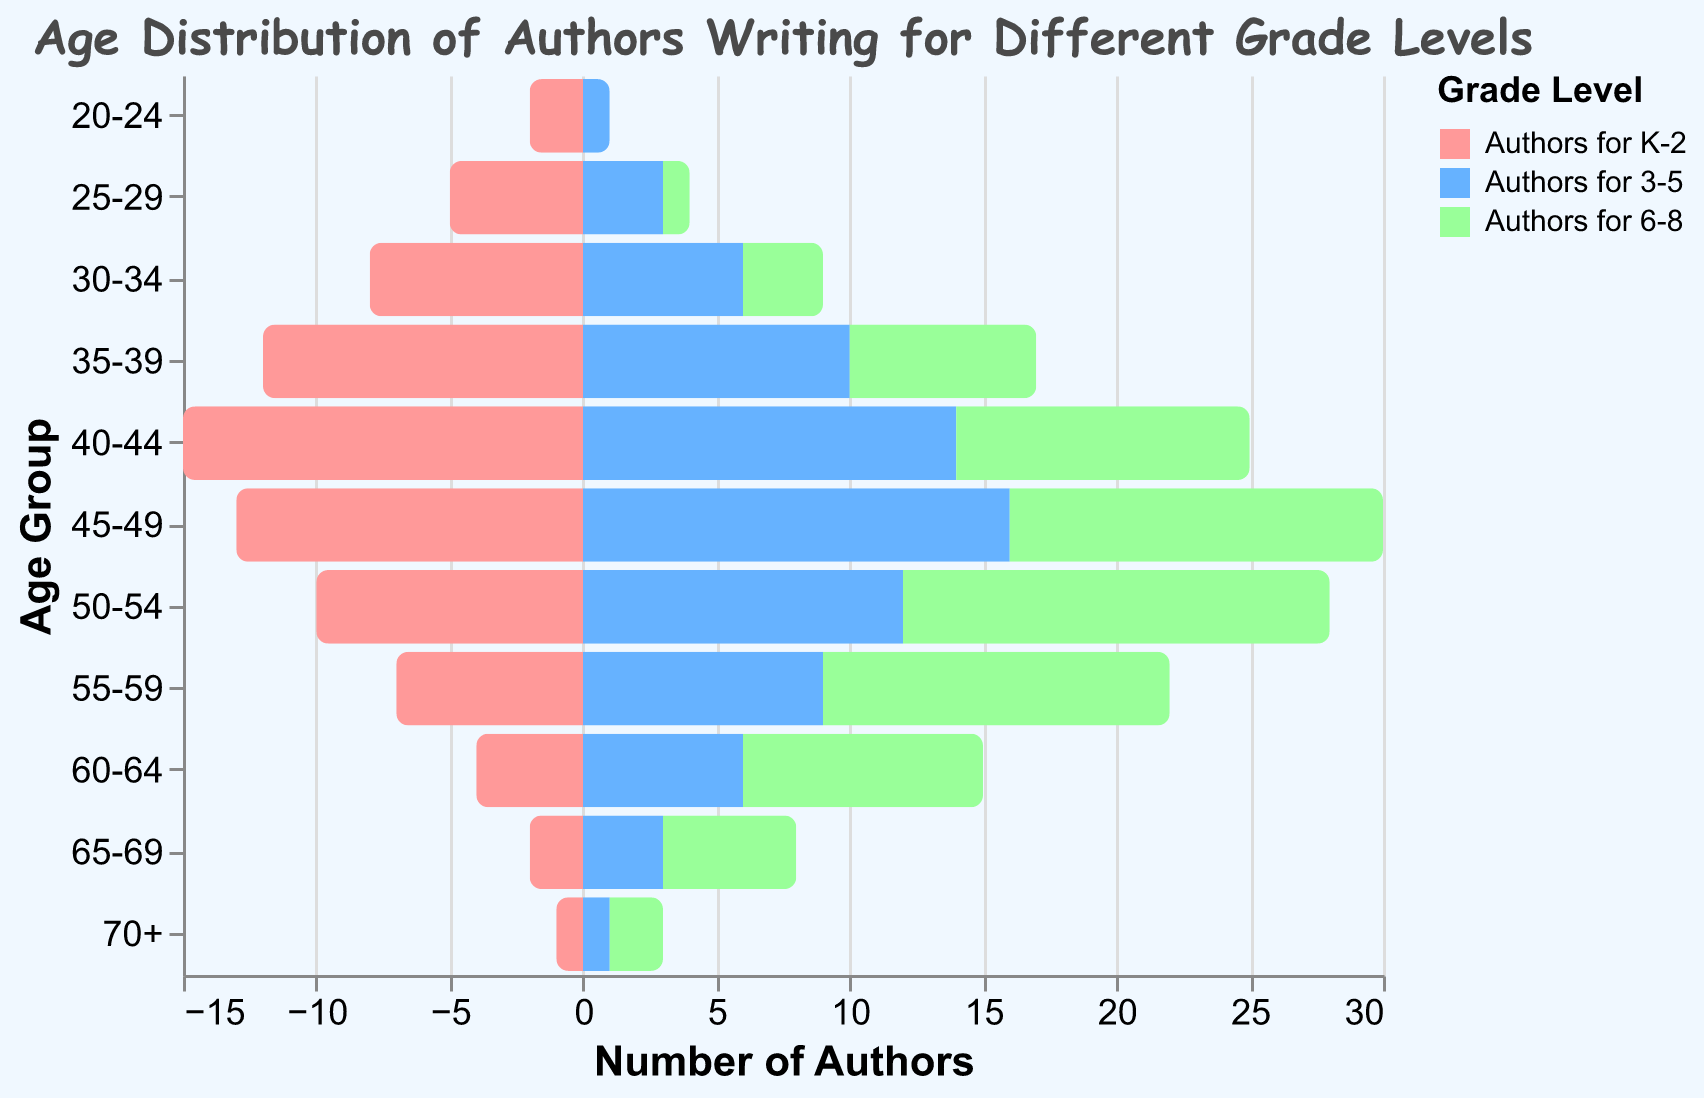What is the title of the figure? The title can be found at the top of the figure as a textual element.
Answer: Age Distribution of Authors Writing for Different Grade Levels What age group has the most authors writing for K-2? By looking at the bars for K-2 authors, the longest bar indicates the age group with the most authors.
Answer: 40-44 How many authors aged 50-54 write for grades 3-5? Locate the bar representing 50-54 age group under the color for grade 3-5 and refer to the tooltip or axis.
Answer: 12 What is the sum of authors in the 35-39 age group for all grade levels? Sum the values across all three categories (K-2, 3-5, 6-8) for the 35-39 age group: 12 + 10 + 7.
Answer: 29 Which age group has the fewest authors for grade 6-8? Identify the shortest bar for grade 6-8 authors; refer to the age group it corresponds to.
Answer: 20-24 Compare the number of authors aged 60-64 writing for K-2 and 6-8; which is more? Compare the bar lengths for the 60-64 age group under K-2 and 6-8 categories.
Answer: Authors for 6-8 What is the total number of authors aged 70+? Add the values for all three categories (K-2, 3-5, 6-8) in the 70+ age group: 1 + 1 + 2.
Answer: 4 Which grade level generally has more authors in the 40-49 age range, K-2 or 3-5? Compare the summed values of the 40-44 and 45-49 age groups for each grade level: (15+13) for K-2 and (14+16) for 3-5.
Answer: 3-5 What is the difference in the number of authors aged 30-34 writing for K-2 and 6-8? Subtract the number of authors for 6-8 from the number of authors for K-2 in the 30-34 age group: 8 - 3.
Answer: 5 How does the distribution of authors aged 55-59 differ between grades 3-5 and 6-8? Compare the values for 3-5 and 6-8 within the same age group: 9 for 3-5 and 13 for 6-8.
Answer: 6-8 has more 